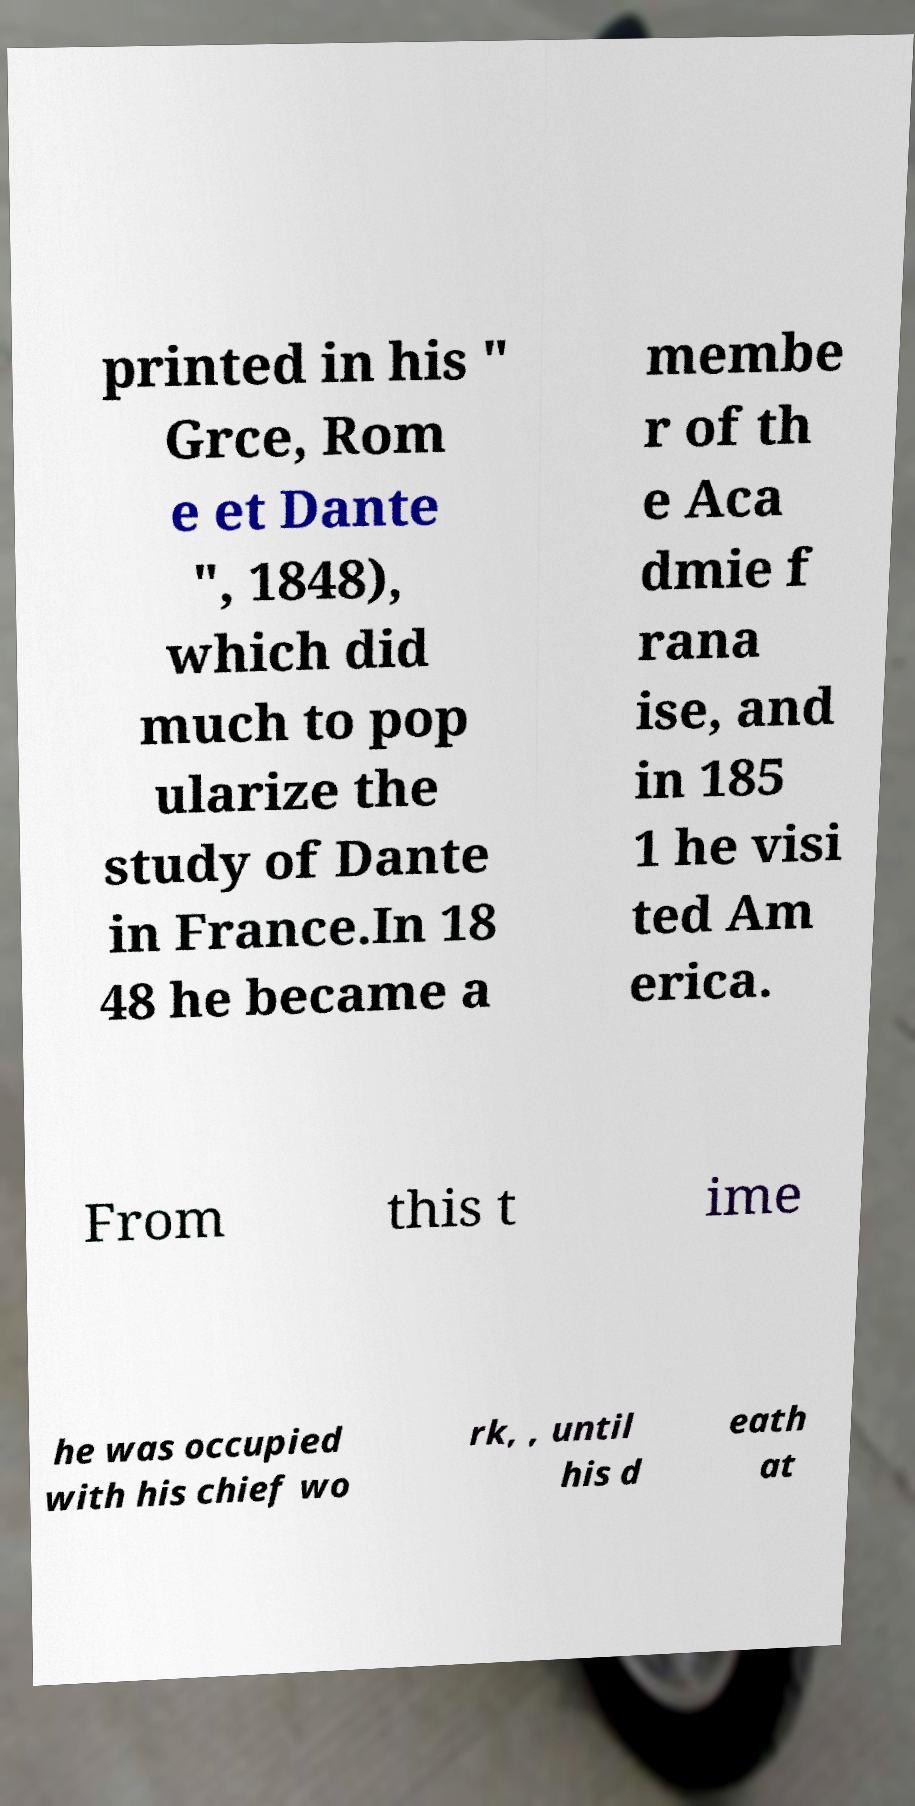Please identify and transcribe the text found in this image. printed in his " Grce, Rom e et Dante ", 1848), which did much to pop ularize the study of Dante in France.In 18 48 he became a membe r of th e Aca dmie f rana ise, and in 185 1 he visi ted Am erica. From this t ime he was occupied with his chief wo rk, , until his d eath at 